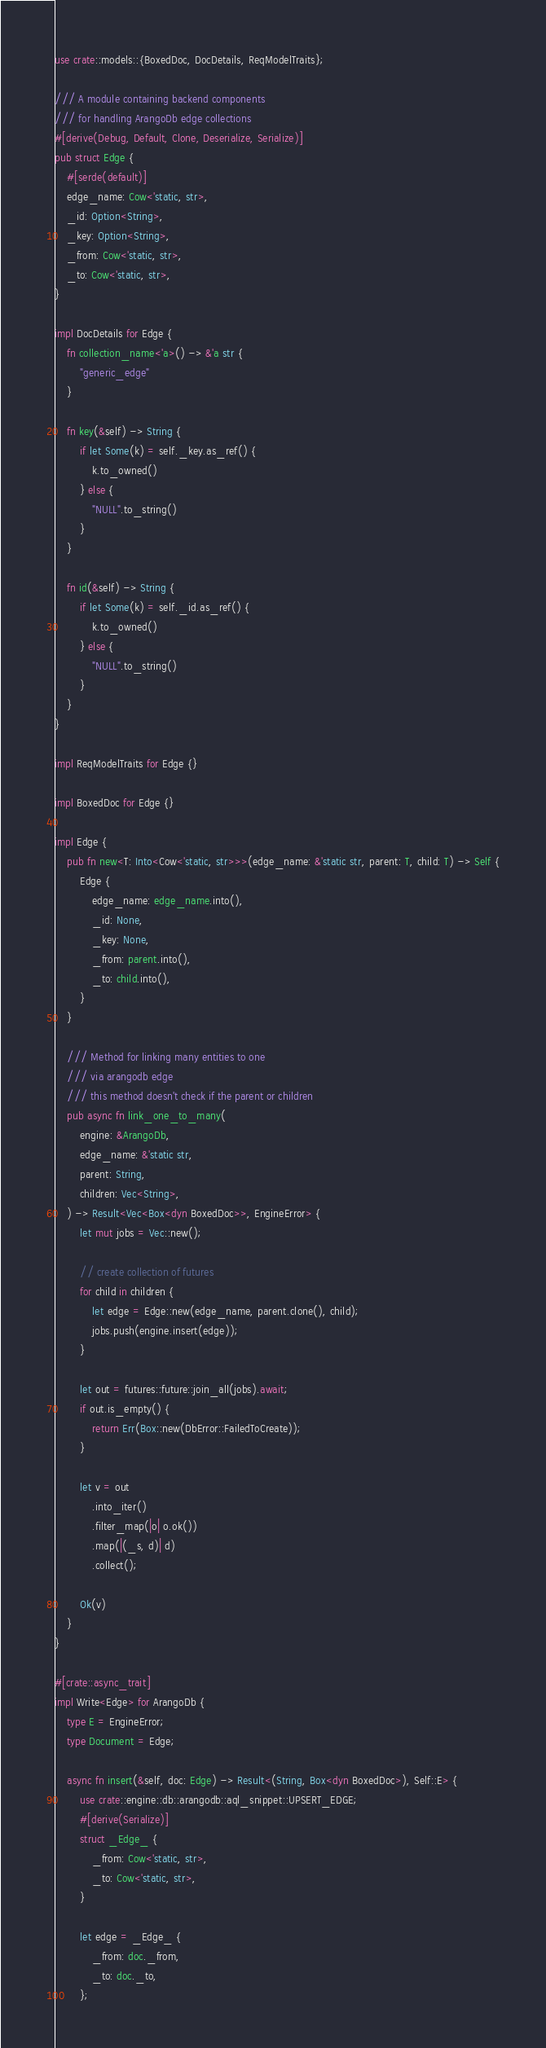Convert code to text. <code><loc_0><loc_0><loc_500><loc_500><_Rust_>use crate::models::{BoxedDoc, DocDetails, ReqModelTraits};

/// A module containing backend components
/// for handling ArangoDb edge collections
#[derive(Debug, Default, Clone, Deserialize, Serialize)]
pub struct Edge {
    #[serde(default)]
    edge_name: Cow<'static, str>,
    _id: Option<String>,
    _key: Option<String>,
    _from: Cow<'static, str>,
    _to: Cow<'static, str>,
}

impl DocDetails for Edge {
    fn collection_name<'a>() -> &'a str {
        "generic_edge"
    }

    fn key(&self) -> String {
        if let Some(k) = self._key.as_ref() {
            k.to_owned()
        } else {
            "NULL".to_string()
        }
    }

    fn id(&self) -> String {
        if let Some(k) = self._id.as_ref() {
            k.to_owned()
        } else {
            "NULL".to_string()
        }
    }
}

impl ReqModelTraits for Edge {}

impl BoxedDoc for Edge {}

impl Edge {
    pub fn new<T: Into<Cow<'static, str>>>(edge_name: &'static str, parent: T, child: T) -> Self {
        Edge {
            edge_name: edge_name.into(),
            _id: None,
            _key: None,
            _from: parent.into(),
            _to: child.into(),
        }
    }

    /// Method for linking many entities to one
    /// via arangodb edge
    /// this method doesn't check if the parent or children
    pub async fn link_one_to_many(
        engine: &ArangoDb,
        edge_name: &'static str,
        parent: String,
        children: Vec<String>,
    ) -> Result<Vec<Box<dyn BoxedDoc>>, EngineError> {
        let mut jobs = Vec::new();

        // create collection of futures
        for child in children {
            let edge = Edge::new(edge_name, parent.clone(), child);
            jobs.push(engine.insert(edge));
        }

        let out = futures::future::join_all(jobs).await;
        if out.is_empty() {
            return Err(Box::new(DbError::FailedToCreate));
        }

        let v = out
            .into_iter()
            .filter_map(|o| o.ok())
            .map(|(_s, d)| d)
            .collect();

        Ok(v)
    }
}

#[crate::async_trait]
impl Write<Edge> for ArangoDb {
    type E = EngineError;
    type Document = Edge;

    async fn insert(&self, doc: Edge) -> Result<(String, Box<dyn BoxedDoc>), Self::E> {
        use crate::engine::db::arangodb::aql_snippet::UPSERT_EDGE;
        #[derive(Serialize)]
        struct _Edge_ {
            _from: Cow<'static, str>,
            _to: Cow<'static, str>,
        }

        let edge = _Edge_ {
            _from: doc._from,
            _to: doc._to,
        };</code> 